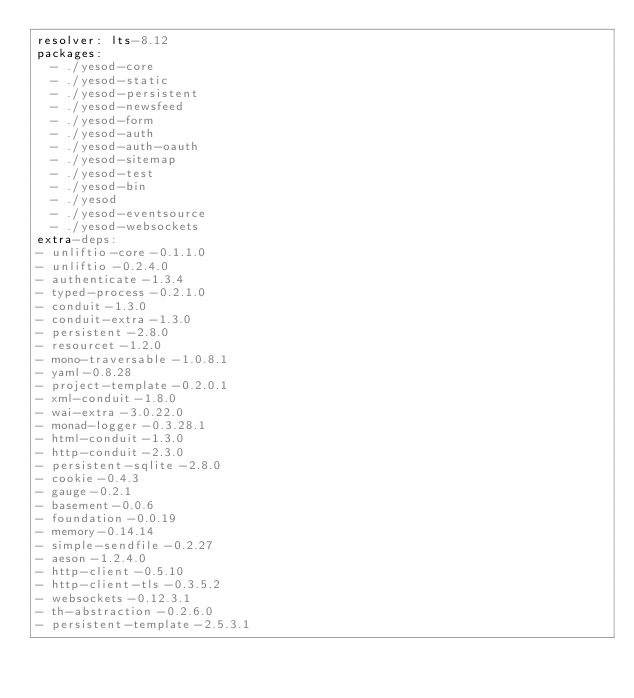Convert code to text. <code><loc_0><loc_0><loc_500><loc_500><_YAML_>resolver: lts-8.12
packages:
  - ./yesod-core
  - ./yesod-static
  - ./yesod-persistent
  - ./yesod-newsfeed
  - ./yesod-form
  - ./yesod-auth
  - ./yesod-auth-oauth
  - ./yesod-sitemap
  - ./yesod-test
  - ./yesod-bin
  - ./yesod
  - ./yesod-eventsource
  - ./yesod-websockets
extra-deps:
- unliftio-core-0.1.1.0
- unliftio-0.2.4.0
- authenticate-1.3.4
- typed-process-0.2.1.0
- conduit-1.3.0
- conduit-extra-1.3.0
- persistent-2.8.0
- resourcet-1.2.0
- mono-traversable-1.0.8.1
- yaml-0.8.28
- project-template-0.2.0.1
- xml-conduit-1.8.0
- wai-extra-3.0.22.0
- monad-logger-0.3.28.1
- html-conduit-1.3.0
- http-conduit-2.3.0
- persistent-sqlite-2.8.0
- cookie-0.4.3
- gauge-0.2.1
- basement-0.0.6
- foundation-0.0.19
- memory-0.14.14
- simple-sendfile-0.2.27
- aeson-1.2.4.0
- http-client-0.5.10
- http-client-tls-0.3.5.2
- websockets-0.12.3.1
- th-abstraction-0.2.6.0
- persistent-template-2.5.3.1
</code> 